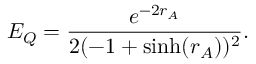<formula> <loc_0><loc_0><loc_500><loc_500>E _ { Q } = \frac { e ^ { - 2 r _ { A } } } { 2 ( - 1 + \sinh ( r _ { A } ) ) ^ { 2 } } .</formula> 